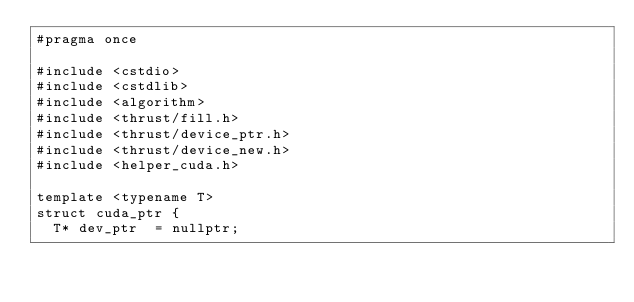<code> <loc_0><loc_0><loc_500><loc_500><_Cuda_>#pragma once

#include <cstdio>
#include <cstdlib>
#include <algorithm>
#include <thrust/fill.h>
#include <thrust/device_ptr.h>
#include <thrust/device_new.h>
#include <helper_cuda.h>

template <typename T>
struct cuda_ptr {
  T* dev_ptr  = nullptr;</code> 